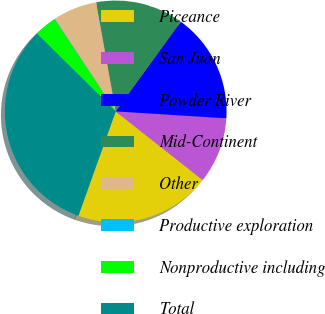<chart> <loc_0><loc_0><loc_500><loc_500><pie_chart><fcel>Piceance<fcel>San Juan<fcel>Powder River<fcel>Mid-Continent<fcel>Other<fcel>Productive exploration<fcel>Nonproductive including<fcel>Total<nl><fcel>19.84%<fcel>9.63%<fcel>16.01%<fcel>12.82%<fcel>6.44%<fcel>0.07%<fcel>3.25%<fcel>31.95%<nl></chart> 